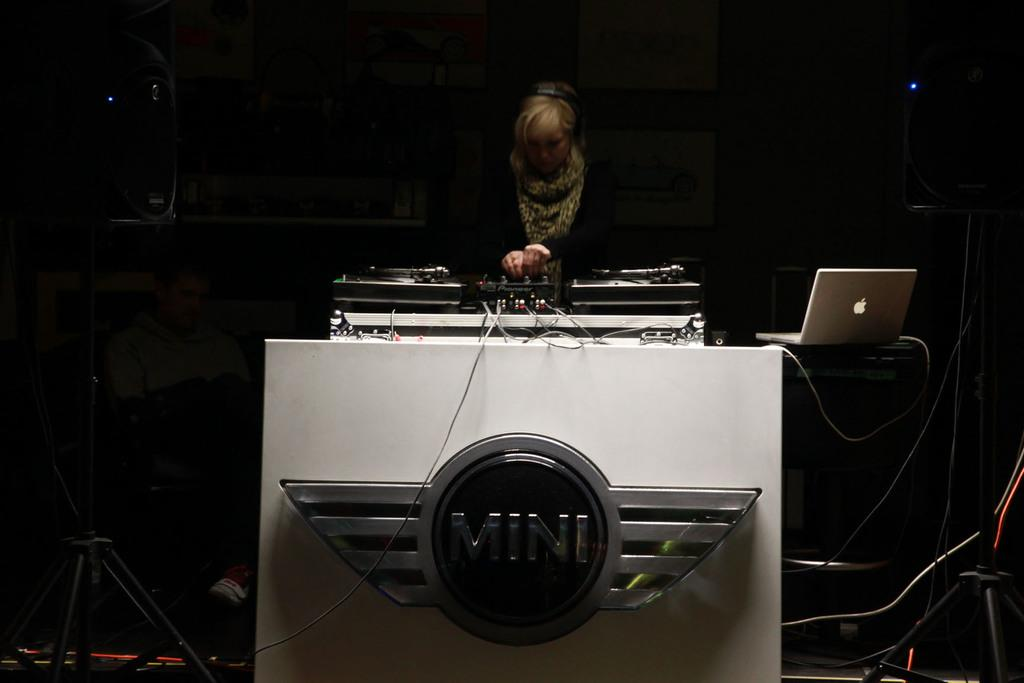Who is the main subject in the image? There is a woman in the image. What is the woman doing in the image? The woman is playing a DJ. Can you describe any other objects or elements in the image? There is a logo in the image, as well as a laptop on the right side of the image. What is the color of the background in the image? The background of the image is dark. Can you see the woman's grandfather in the image? There is no mention of a grandfather in the image, so it cannot be determined if he is present. 